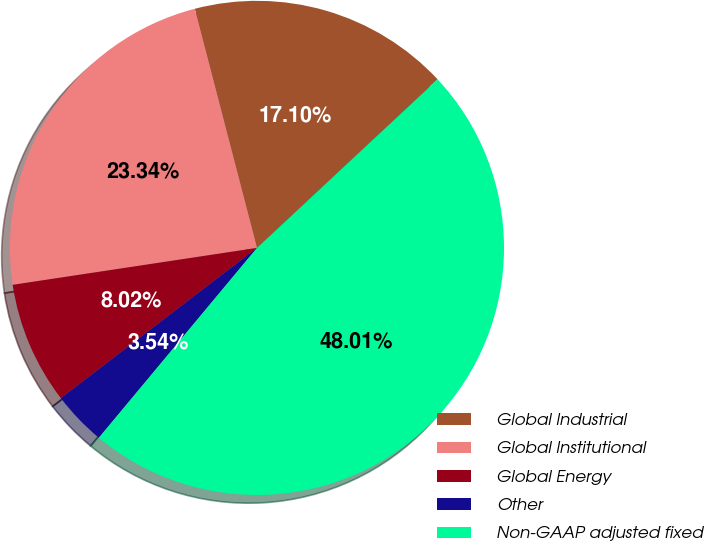<chart> <loc_0><loc_0><loc_500><loc_500><pie_chart><fcel>Global Industrial<fcel>Global Institutional<fcel>Global Energy<fcel>Other<fcel>Non-GAAP adjusted fixed<nl><fcel>17.1%<fcel>23.34%<fcel>8.02%<fcel>3.54%<fcel>48.01%<nl></chart> 